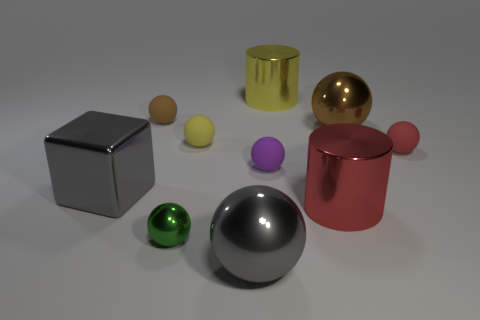Subtract all small brown balls. How many balls are left? 6 Subtract all cyan cylinders. How many brown spheres are left? 2 Subtract 4 balls. How many balls are left? 3 Subtract all red spheres. How many spheres are left? 6 Subtract all cubes. How many objects are left? 9 Subtract all gray spheres. Subtract all green blocks. How many spheres are left? 6 Subtract all big yellow shiny cylinders. Subtract all cyan rubber balls. How many objects are left? 9 Add 2 tiny shiny spheres. How many tiny shiny spheres are left? 3 Add 2 big red shiny cylinders. How many big red shiny cylinders exist? 3 Subtract 0 purple cylinders. How many objects are left? 10 